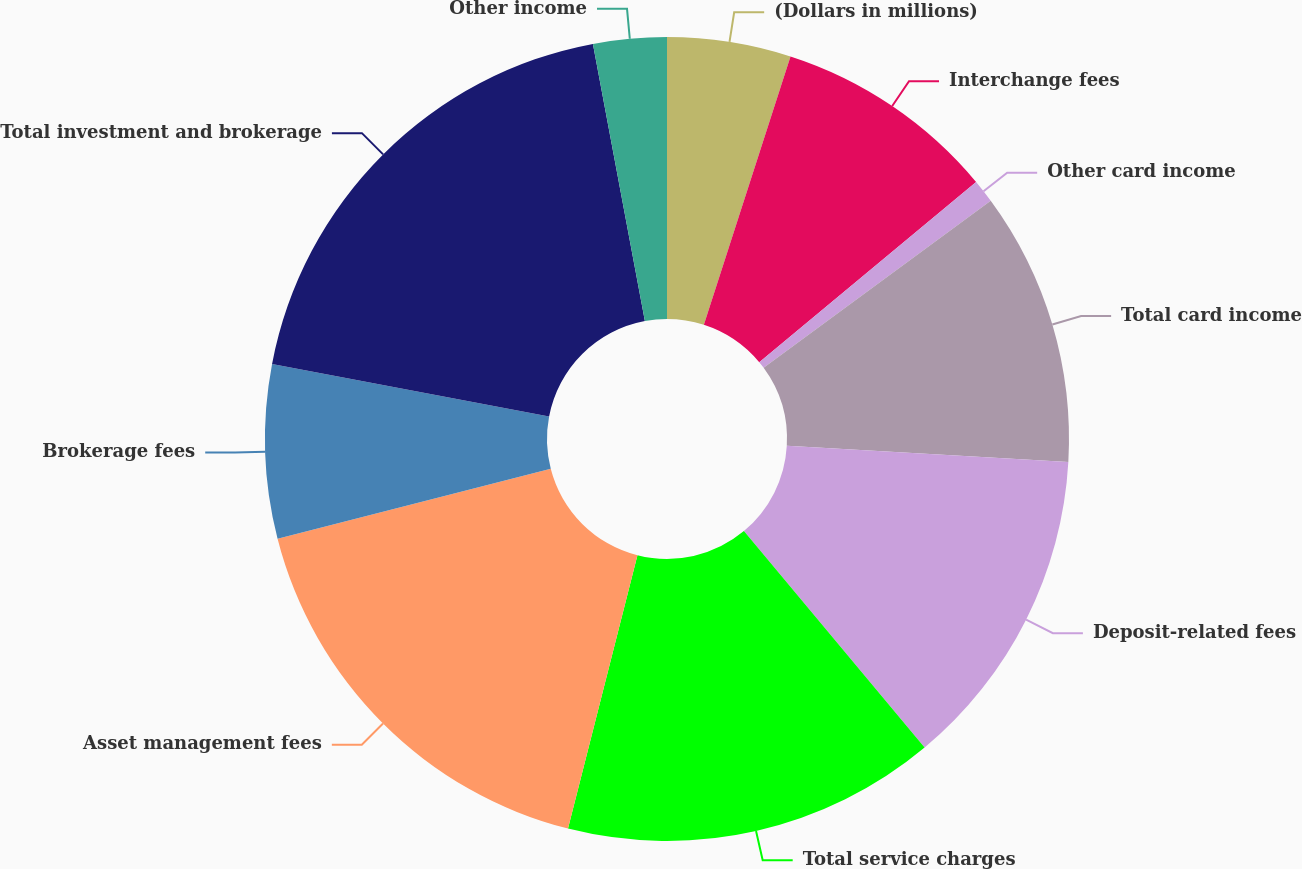<chart> <loc_0><loc_0><loc_500><loc_500><pie_chart><fcel>(Dollars in millions)<fcel>Interchange fees<fcel>Other card income<fcel>Total card income<fcel>Deposit-related fees<fcel>Total service charges<fcel>Asset management fees<fcel>Brokerage fees<fcel>Total investment and brokerage<fcel>Other income<nl><fcel>4.97%<fcel>8.99%<fcel>0.94%<fcel>11.01%<fcel>13.02%<fcel>15.03%<fcel>17.05%<fcel>6.98%<fcel>19.06%<fcel>2.95%<nl></chart> 